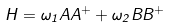<formula> <loc_0><loc_0><loc_500><loc_500>H = \omega _ { 1 } A A ^ { + } + \omega _ { 2 } B B ^ { + }</formula> 